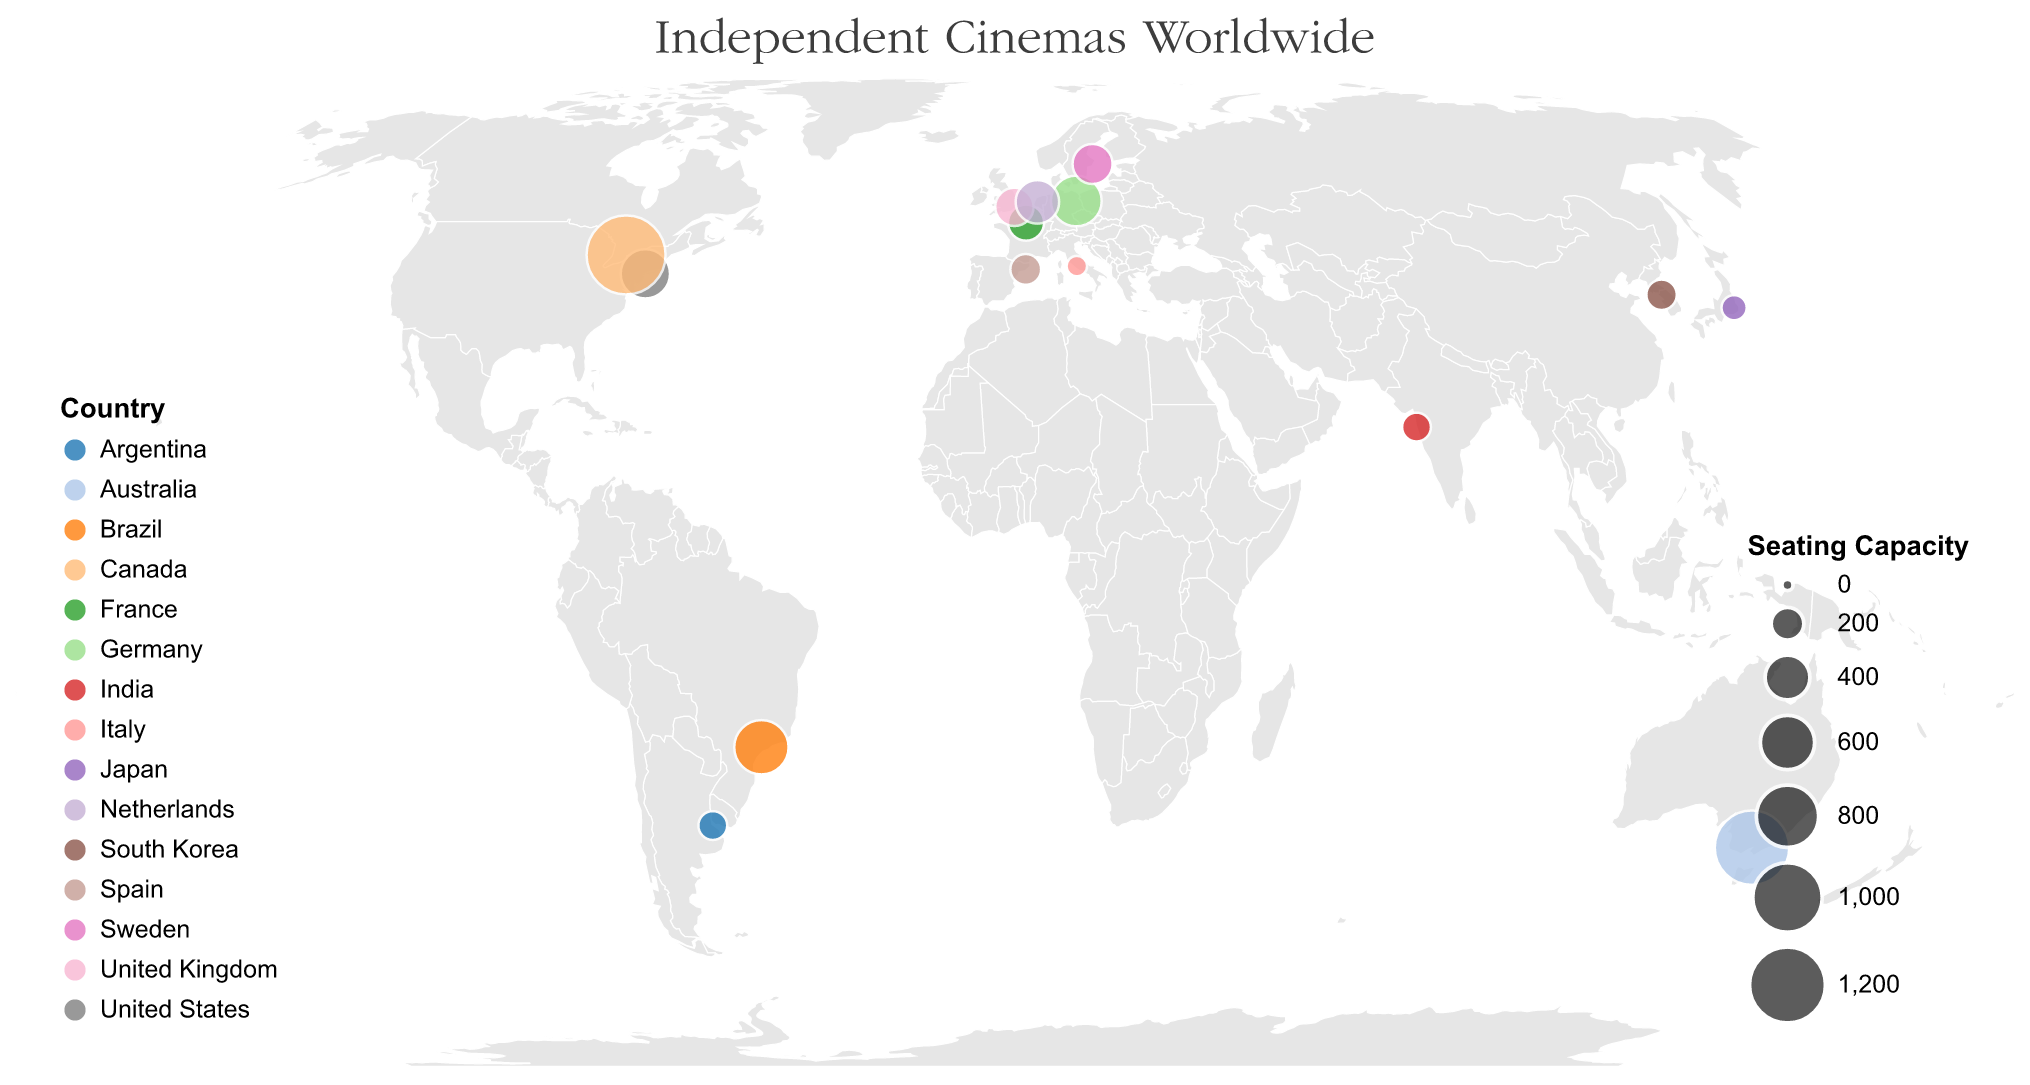How many independent cinemas are shown on the map? Look at the number of circles plotted on the map. Each circle represents one independent cinema. By counting them, you can determine the total number of cinemas.
Answer: 15 Which cinema has the largest seating capacity, and where is it located? Look for the circle with the largest size. According to the tooltip and the size scale, the largest circle represents the TIFF Bell Lightbox in Toronto, Canada, with a seating capacity of 1300.
Answer: TIFF Bell Lightbox, Toronto, Canada Which two countries have the most number of independent cinemas according to this plot? By checking the color legend and counting the appearances of each country's color among the circles, the United States and Argentina have one cinema each which is not the answer. Count the remaining circles correctly. France, Germany, and Italy also have one each. Canada, UK, Japan, Australia, Spain, India, Brazil, South Korea, Sweden, Netherlands have one each. It suggests the representation is unique among the counts, so identify by highlighting multiple regions such as spread among continents instead.
Answer: All highlighted evenly Compare the seating capacities of cinemas in Tokyo and Seoul. Which city has a higher total seating capacity? Refer to the figure's tooltip or legend to find the seating capacities for the independent cinemas in Tokyo and Seoul. Tokyo has Uplink Shibuya with 108 seats, and Seoul has Cinecube with 170 seats.
Answer: Seoul What is the average seating capacity of the independent cinemas in Europe displayed on the map? First, identify the European cities: Paris (France), London (United Kingdom), Berlin (Germany), Barcelona (Spain), Rome (Italy), Stockholm (Sweden), and Amsterdam (Netherlands). Their seating capacities are 250, 285, 520, 175, 63, 314, and 376 respectively. Sum these values (250 + 285 + 520 + 175 + 63 + 314 + 376 = 1983) and divide by the number of cinemas (7).
Answer: 283.29 Which cinema is located furthest east? To find the cinema furthest east, look for the circle with the highest longitude value. According to the plot, Uplink Shibuya in Tokyo, Japan, has the highest longitude (139.7046).
Answer: Uplink Shibuya Which city has the smallest independent cinema in terms of seating capacity, and what is its capacity? Identify the circle with the smallest size. The smallest circle corresponds to Cinema dei Piccoli in Rome, Italy, with a seating capacity of 63.
Answer: Rome, 63 How many independent cinemas are located in the Southern Hemisphere? Identify cinemas with latitude values less than 0. These are: The Astor Theatre in Melbourne, Australia, and Cine Belas Artes in São Paulo, Brazil.
Answer: 2 What is the total seating capacity of independent cinemas in North America according to this plot? Identify the cinemas located in North America: Film Forum in New York and TIFF Bell Lightbox in Toronto. Sum their seating capacities (489 + 1300).
Answer: 1789 